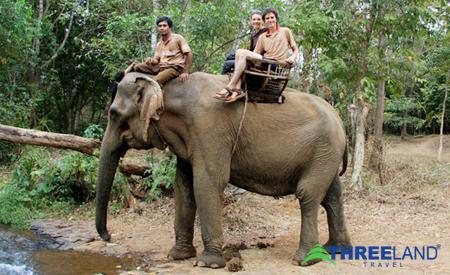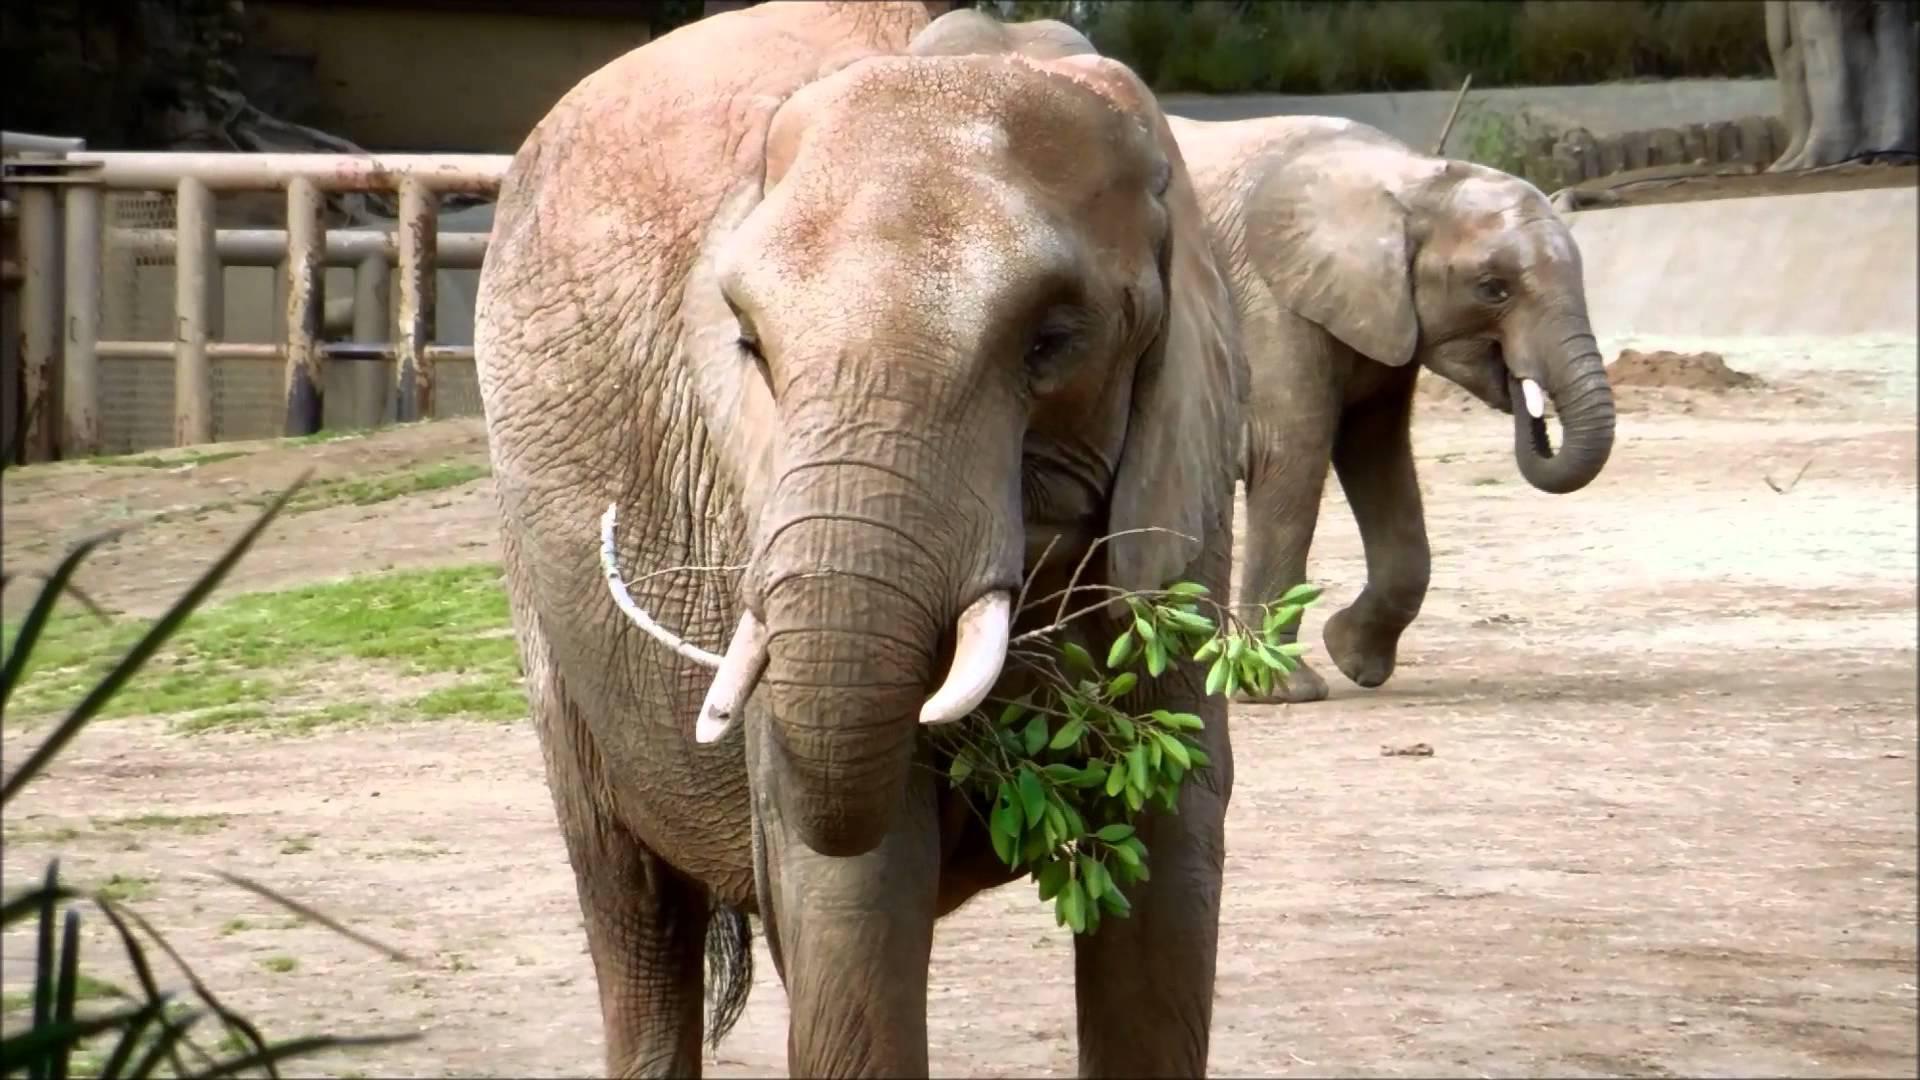The first image is the image on the left, the second image is the image on the right. For the images shown, is this caption "One of the elephants is facing upwards." true? Answer yes or no. No. 